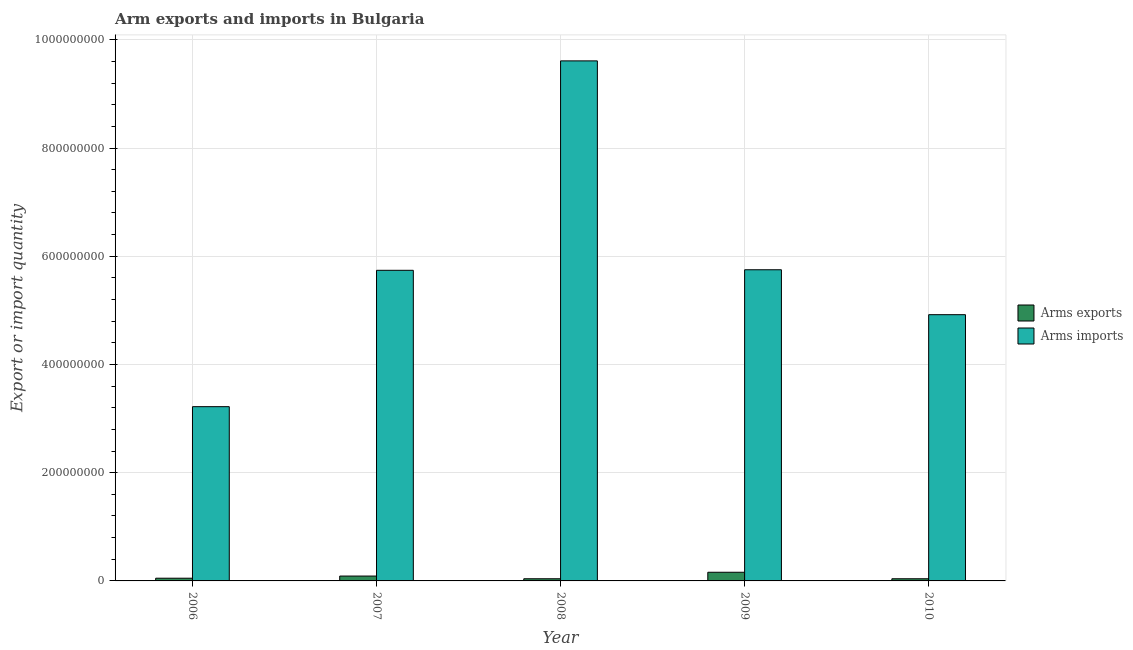How many different coloured bars are there?
Keep it short and to the point. 2. How many groups of bars are there?
Make the answer very short. 5. Are the number of bars on each tick of the X-axis equal?
Your response must be concise. Yes. How many bars are there on the 4th tick from the left?
Keep it short and to the point. 2. What is the arms exports in 2010?
Make the answer very short. 4.00e+06. Across all years, what is the maximum arms exports?
Give a very brief answer. 1.60e+07. Across all years, what is the minimum arms imports?
Make the answer very short. 3.22e+08. In which year was the arms exports maximum?
Your response must be concise. 2009. What is the total arms imports in the graph?
Ensure brevity in your answer.  2.92e+09. What is the difference between the arms imports in 2007 and that in 2008?
Your answer should be very brief. -3.87e+08. What is the difference between the arms imports in 2010 and the arms exports in 2007?
Ensure brevity in your answer.  -8.20e+07. What is the average arms exports per year?
Ensure brevity in your answer.  7.60e+06. In how many years, is the arms imports greater than 360000000?
Keep it short and to the point. 4. What is the ratio of the arms imports in 2006 to that in 2010?
Ensure brevity in your answer.  0.65. What is the difference between the highest and the second highest arms exports?
Provide a succinct answer. 7.00e+06. What is the difference between the highest and the lowest arms exports?
Offer a very short reply. 1.20e+07. In how many years, is the arms exports greater than the average arms exports taken over all years?
Provide a succinct answer. 2. Is the sum of the arms exports in 2008 and 2010 greater than the maximum arms imports across all years?
Provide a short and direct response. No. What does the 1st bar from the left in 2009 represents?
Give a very brief answer. Arms exports. What does the 2nd bar from the right in 2007 represents?
Offer a terse response. Arms exports. How many bars are there?
Offer a terse response. 10. What is the difference between two consecutive major ticks on the Y-axis?
Offer a very short reply. 2.00e+08. Are the values on the major ticks of Y-axis written in scientific E-notation?
Provide a succinct answer. No. Does the graph contain grids?
Provide a short and direct response. Yes. Where does the legend appear in the graph?
Give a very brief answer. Center right. What is the title of the graph?
Offer a terse response. Arm exports and imports in Bulgaria. What is the label or title of the X-axis?
Provide a succinct answer. Year. What is the label or title of the Y-axis?
Ensure brevity in your answer.  Export or import quantity. What is the Export or import quantity in Arms exports in 2006?
Your answer should be very brief. 5.00e+06. What is the Export or import quantity in Arms imports in 2006?
Make the answer very short. 3.22e+08. What is the Export or import quantity in Arms exports in 2007?
Offer a very short reply. 9.00e+06. What is the Export or import quantity in Arms imports in 2007?
Your response must be concise. 5.74e+08. What is the Export or import quantity in Arms exports in 2008?
Give a very brief answer. 4.00e+06. What is the Export or import quantity in Arms imports in 2008?
Ensure brevity in your answer.  9.61e+08. What is the Export or import quantity in Arms exports in 2009?
Keep it short and to the point. 1.60e+07. What is the Export or import quantity in Arms imports in 2009?
Give a very brief answer. 5.75e+08. What is the Export or import quantity in Arms exports in 2010?
Your response must be concise. 4.00e+06. What is the Export or import quantity in Arms imports in 2010?
Keep it short and to the point. 4.92e+08. Across all years, what is the maximum Export or import quantity of Arms exports?
Your answer should be very brief. 1.60e+07. Across all years, what is the maximum Export or import quantity in Arms imports?
Your answer should be compact. 9.61e+08. Across all years, what is the minimum Export or import quantity of Arms imports?
Your answer should be compact. 3.22e+08. What is the total Export or import quantity in Arms exports in the graph?
Offer a terse response. 3.80e+07. What is the total Export or import quantity in Arms imports in the graph?
Keep it short and to the point. 2.92e+09. What is the difference between the Export or import quantity of Arms imports in 2006 and that in 2007?
Keep it short and to the point. -2.52e+08. What is the difference between the Export or import quantity of Arms exports in 2006 and that in 2008?
Your response must be concise. 1.00e+06. What is the difference between the Export or import quantity of Arms imports in 2006 and that in 2008?
Provide a short and direct response. -6.39e+08. What is the difference between the Export or import quantity of Arms exports in 2006 and that in 2009?
Make the answer very short. -1.10e+07. What is the difference between the Export or import quantity in Arms imports in 2006 and that in 2009?
Offer a very short reply. -2.53e+08. What is the difference between the Export or import quantity of Arms exports in 2006 and that in 2010?
Your response must be concise. 1.00e+06. What is the difference between the Export or import quantity of Arms imports in 2006 and that in 2010?
Provide a short and direct response. -1.70e+08. What is the difference between the Export or import quantity of Arms exports in 2007 and that in 2008?
Ensure brevity in your answer.  5.00e+06. What is the difference between the Export or import quantity in Arms imports in 2007 and that in 2008?
Your answer should be very brief. -3.87e+08. What is the difference between the Export or import quantity of Arms exports in 2007 and that in 2009?
Provide a short and direct response. -7.00e+06. What is the difference between the Export or import quantity of Arms imports in 2007 and that in 2009?
Keep it short and to the point. -1.00e+06. What is the difference between the Export or import quantity in Arms exports in 2007 and that in 2010?
Keep it short and to the point. 5.00e+06. What is the difference between the Export or import quantity in Arms imports in 2007 and that in 2010?
Your response must be concise. 8.20e+07. What is the difference between the Export or import quantity of Arms exports in 2008 and that in 2009?
Provide a succinct answer. -1.20e+07. What is the difference between the Export or import quantity of Arms imports in 2008 and that in 2009?
Provide a short and direct response. 3.86e+08. What is the difference between the Export or import quantity in Arms imports in 2008 and that in 2010?
Make the answer very short. 4.69e+08. What is the difference between the Export or import quantity in Arms imports in 2009 and that in 2010?
Offer a very short reply. 8.30e+07. What is the difference between the Export or import quantity in Arms exports in 2006 and the Export or import quantity in Arms imports in 2007?
Your answer should be very brief. -5.69e+08. What is the difference between the Export or import quantity of Arms exports in 2006 and the Export or import quantity of Arms imports in 2008?
Your response must be concise. -9.56e+08. What is the difference between the Export or import quantity of Arms exports in 2006 and the Export or import quantity of Arms imports in 2009?
Offer a terse response. -5.70e+08. What is the difference between the Export or import quantity of Arms exports in 2006 and the Export or import quantity of Arms imports in 2010?
Make the answer very short. -4.87e+08. What is the difference between the Export or import quantity in Arms exports in 2007 and the Export or import quantity in Arms imports in 2008?
Provide a succinct answer. -9.52e+08. What is the difference between the Export or import quantity in Arms exports in 2007 and the Export or import quantity in Arms imports in 2009?
Offer a very short reply. -5.66e+08. What is the difference between the Export or import quantity in Arms exports in 2007 and the Export or import quantity in Arms imports in 2010?
Your response must be concise. -4.83e+08. What is the difference between the Export or import quantity in Arms exports in 2008 and the Export or import quantity in Arms imports in 2009?
Your answer should be very brief. -5.71e+08. What is the difference between the Export or import quantity of Arms exports in 2008 and the Export or import quantity of Arms imports in 2010?
Your answer should be very brief. -4.88e+08. What is the difference between the Export or import quantity of Arms exports in 2009 and the Export or import quantity of Arms imports in 2010?
Provide a short and direct response. -4.76e+08. What is the average Export or import quantity of Arms exports per year?
Give a very brief answer. 7.60e+06. What is the average Export or import quantity in Arms imports per year?
Give a very brief answer. 5.85e+08. In the year 2006, what is the difference between the Export or import quantity of Arms exports and Export or import quantity of Arms imports?
Keep it short and to the point. -3.17e+08. In the year 2007, what is the difference between the Export or import quantity of Arms exports and Export or import quantity of Arms imports?
Ensure brevity in your answer.  -5.65e+08. In the year 2008, what is the difference between the Export or import quantity in Arms exports and Export or import quantity in Arms imports?
Offer a terse response. -9.57e+08. In the year 2009, what is the difference between the Export or import quantity in Arms exports and Export or import quantity in Arms imports?
Ensure brevity in your answer.  -5.59e+08. In the year 2010, what is the difference between the Export or import quantity of Arms exports and Export or import quantity of Arms imports?
Ensure brevity in your answer.  -4.88e+08. What is the ratio of the Export or import quantity in Arms exports in 2006 to that in 2007?
Make the answer very short. 0.56. What is the ratio of the Export or import quantity in Arms imports in 2006 to that in 2007?
Offer a terse response. 0.56. What is the ratio of the Export or import quantity of Arms exports in 2006 to that in 2008?
Ensure brevity in your answer.  1.25. What is the ratio of the Export or import quantity of Arms imports in 2006 to that in 2008?
Provide a succinct answer. 0.34. What is the ratio of the Export or import quantity in Arms exports in 2006 to that in 2009?
Your answer should be very brief. 0.31. What is the ratio of the Export or import quantity in Arms imports in 2006 to that in 2009?
Keep it short and to the point. 0.56. What is the ratio of the Export or import quantity of Arms imports in 2006 to that in 2010?
Keep it short and to the point. 0.65. What is the ratio of the Export or import quantity in Arms exports in 2007 to that in 2008?
Give a very brief answer. 2.25. What is the ratio of the Export or import quantity in Arms imports in 2007 to that in 2008?
Offer a terse response. 0.6. What is the ratio of the Export or import quantity of Arms exports in 2007 to that in 2009?
Offer a very short reply. 0.56. What is the ratio of the Export or import quantity in Arms imports in 2007 to that in 2009?
Provide a short and direct response. 1. What is the ratio of the Export or import quantity of Arms exports in 2007 to that in 2010?
Provide a succinct answer. 2.25. What is the ratio of the Export or import quantity of Arms exports in 2008 to that in 2009?
Offer a terse response. 0.25. What is the ratio of the Export or import quantity of Arms imports in 2008 to that in 2009?
Give a very brief answer. 1.67. What is the ratio of the Export or import quantity of Arms imports in 2008 to that in 2010?
Provide a short and direct response. 1.95. What is the ratio of the Export or import quantity of Arms imports in 2009 to that in 2010?
Your answer should be very brief. 1.17. What is the difference between the highest and the second highest Export or import quantity of Arms imports?
Provide a succinct answer. 3.86e+08. What is the difference between the highest and the lowest Export or import quantity of Arms exports?
Your answer should be very brief. 1.20e+07. What is the difference between the highest and the lowest Export or import quantity of Arms imports?
Offer a very short reply. 6.39e+08. 